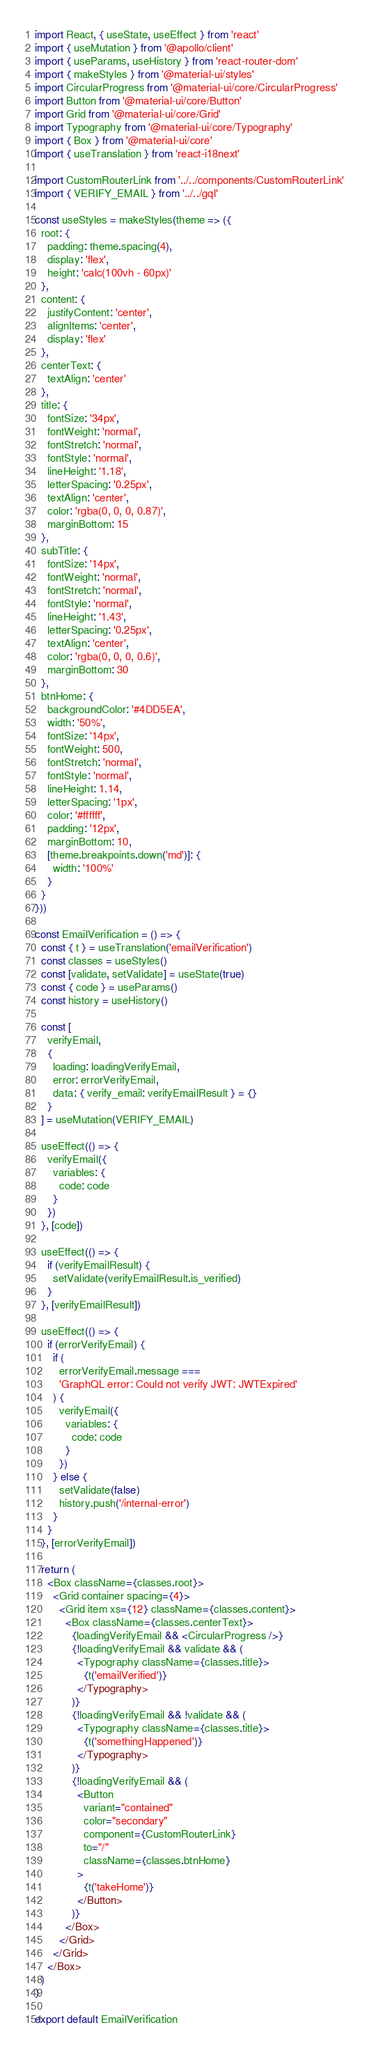Convert code to text. <code><loc_0><loc_0><loc_500><loc_500><_JavaScript_>import React, { useState, useEffect } from 'react'
import { useMutation } from '@apollo/client'
import { useParams, useHistory } from 'react-router-dom'
import { makeStyles } from '@material-ui/styles'
import CircularProgress from '@material-ui/core/CircularProgress'
import Button from '@material-ui/core/Button'
import Grid from '@material-ui/core/Grid'
import Typography from '@material-ui/core/Typography'
import { Box } from '@material-ui/core'
import { useTranslation } from 'react-i18next'

import CustomRouterLink from '../../components/CustomRouterLink'
import { VERIFY_EMAIL } from '../../gql'

const useStyles = makeStyles(theme => ({
  root: {
    padding: theme.spacing(4),
    display: 'flex',
    height: 'calc(100vh - 60px)'
  },
  content: {
    justifyContent: 'center',
    alignItems: 'center',
    display: 'flex'
  },
  centerText: {
    textAlign: 'center'
  },
  title: {
    fontSize: '34px',
    fontWeight: 'normal',
    fontStretch: 'normal',
    fontStyle: 'normal',
    lineHeight: '1.18',
    letterSpacing: '0.25px',
    textAlign: 'center',
    color: 'rgba(0, 0, 0, 0.87)',
    marginBottom: 15
  },
  subTitle: {
    fontSize: '14px',
    fontWeight: 'normal',
    fontStretch: 'normal',
    fontStyle: 'normal',
    lineHeight: '1.43',
    letterSpacing: '0.25px',
    textAlign: 'center',
    color: 'rgba(0, 0, 0, 0.6)',
    marginBottom: 30
  },
  btnHome: {
    backgroundColor: '#4DD5EA',
    width: '50%',
    fontSize: '14px',
    fontWeight: 500,
    fontStretch: 'normal',
    fontStyle: 'normal',
    lineHeight: 1.14,
    letterSpacing: '1px',
    color: '#ffffff',
    padding: '12px',
    marginBottom: 10,
    [theme.breakpoints.down('md')]: {
      width: '100%'
    }
  }
}))

const EmailVerification = () => {
  const { t } = useTranslation('emailVerification')
  const classes = useStyles()
  const [validate, setValidate] = useState(true)
  const { code } = useParams()
  const history = useHistory()

  const [
    verifyEmail,
    {
      loading: loadingVerifyEmail,
      error: errorVerifyEmail,
      data: { verify_email: verifyEmailResult } = {}
    }
  ] = useMutation(VERIFY_EMAIL)

  useEffect(() => {
    verifyEmail({
      variables: {
        code: code
      }
    })
  }, [code])

  useEffect(() => {
    if (verifyEmailResult) {
      setValidate(verifyEmailResult.is_verified)
    }
  }, [verifyEmailResult])

  useEffect(() => {
    if (errorVerifyEmail) {
      if (
        errorVerifyEmail.message ===
        'GraphQL error: Could not verify JWT: JWTExpired'
      ) {
        verifyEmail({
          variables: {
            code: code
          }
        })
      } else {
        setValidate(false)
        history.push('/internal-error')
      }
    }
  }, [errorVerifyEmail])

  return (
    <Box className={classes.root}>
      <Grid container spacing={4}>
        <Grid item xs={12} className={classes.content}>
          <Box className={classes.centerText}>
            {loadingVerifyEmail && <CircularProgress />}
            {!loadingVerifyEmail && validate && (
              <Typography className={classes.title}>
                {t('emailVerified')}
              </Typography>
            )}
            {!loadingVerifyEmail && !validate && (
              <Typography className={classes.title}>
                {t('somethingHappened')}
              </Typography>
            )}
            {!loadingVerifyEmail && (
              <Button
                variant="contained"
                color="secondary"
                component={CustomRouterLink}
                to="/"
                className={classes.btnHome}
              >
                {t('takeHome')}
              </Button>
            )}
          </Box>
        </Grid>
      </Grid>
    </Box>
  )
}

export default EmailVerification
</code> 